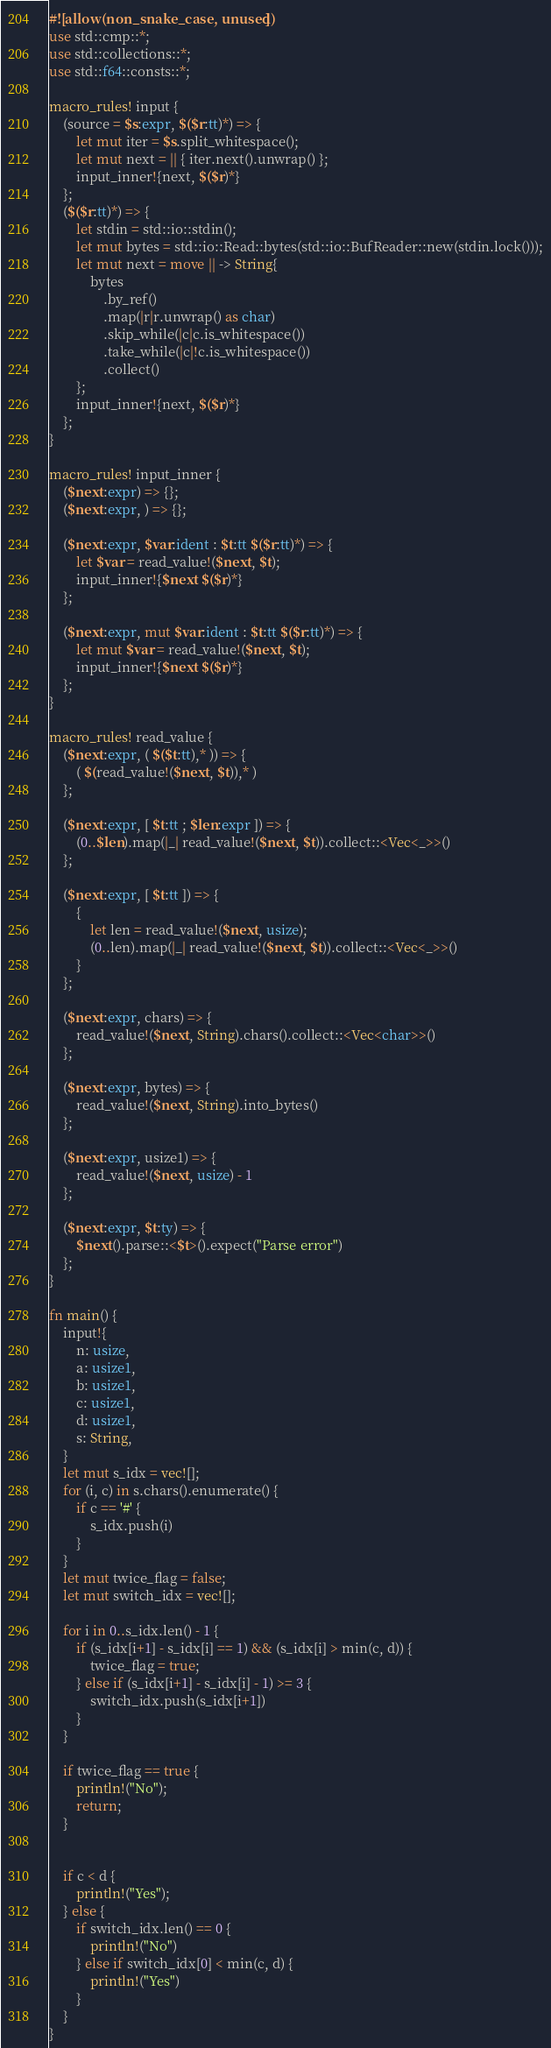Convert code to text. <code><loc_0><loc_0><loc_500><loc_500><_Rust_>#![allow(non_snake_case, unused)]
use std::cmp::*;
use std::collections::*;
use std::f64::consts::*;

macro_rules! input {
    (source = $s:expr, $($r:tt)*) => {
        let mut iter = $s.split_whitespace();
        let mut next = || { iter.next().unwrap() };
        input_inner!{next, $($r)*}
    };
    ($($r:tt)*) => {
        let stdin = std::io::stdin();
        let mut bytes = std::io::Read::bytes(std::io::BufReader::new(stdin.lock()));
        let mut next = move || -> String{
            bytes
                .by_ref()
                .map(|r|r.unwrap() as char)
                .skip_while(|c|c.is_whitespace())
                .take_while(|c|!c.is_whitespace())
                .collect()
        };
        input_inner!{next, $($r)*}
    };
}

macro_rules! input_inner {
    ($next:expr) => {};
    ($next:expr, ) => {};

    ($next:expr, $var:ident : $t:tt $($r:tt)*) => {
        let $var = read_value!($next, $t);
        input_inner!{$next $($r)*}
    };

    ($next:expr, mut $var:ident : $t:tt $($r:tt)*) => {
        let mut $var = read_value!($next, $t);
        input_inner!{$next $($r)*}
    };
}

macro_rules! read_value {
    ($next:expr, ( $($t:tt),* )) => {
        ( $(read_value!($next, $t)),* )
    };

    ($next:expr, [ $t:tt ; $len:expr ]) => {
        (0..$len).map(|_| read_value!($next, $t)).collect::<Vec<_>>()
    };

    ($next:expr, [ $t:tt ]) => {
        {
            let len = read_value!($next, usize);
            (0..len).map(|_| read_value!($next, $t)).collect::<Vec<_>>()
        }
    };

    ($next:expr, chars) => {
        read_value!($next, String).chars().collect::<Vec<char>>()
    };

    ($next:expr, bytes) => {
        read_value!($next, String).into_bytes()
    };

    ($next:expr, usize1) => {
        read_value!($next, usize) - 1
    };

    ($next:expr, $t:ty) => {
        $next().parse::<$t>().expect("Parse error")
    };
}

fn main() {
    input!{
        n: usize,
        a: usize1,
        b: usize1,
        c: usize1,
        d: usize1,
        s: String,
    }
    let mut s_idx = vec![];
    for (i, c) in s.chars().enumerate() {
        if c == '#' {
            s_idx.push(i)
        }
    }
    let mut twice_flag = false;
    let mut switch_idx = vec![];

    for i in 0..s_idx.len() - 1 {
        if (s_idx[i+1] - s_idx[i] == 1) && (s_idx[i] > min(c, d)) {
            twice_flag = true;
        } else if (s_idx[i+1] - s_idx[i] - 1) >= 3 {
            switch_idx.push(s_idx[i+1])
        } 
    }

    if twice_flag == true {
        println!("No");
        return;
    }


    if c < d {
        println!("Yes");
    } else {
        if switch_idx.len() == 0 {
            println!("No")
        } else if switch_idx[0] < min(c, d) {
            println!("Yes")
        }
    }
}
</code> 